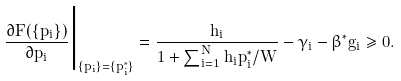Convert formula to latex. <formula><loc_0><loc_0><loc_500><loc_500>\frac { \partial F ( \{ p _ { i } \} ) } { \partial p _ { i } } \Big | _ { \{ p _ { i } \} = \{ p ^ { \ast } _ { i } \} } = \frac { h _ { i } } { 1 + \sum ^ { N } _ { i = 1 } h _ { i } p ^ { \ast } _ { i } / W } - \gamma _ { i } - \beta ^ { \ast } g _ { i } \geq 0 .</formula> 